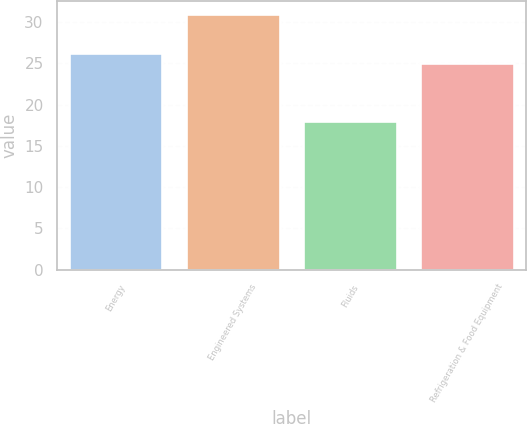Convert chart. <chart><loc_0><loc_0><loc_500><loc_500><bar_chart><fcel>Energy<fcel>Engineered Systems<fcel>Fluids<fcel>Refrigeration & Food Equipment<nl><fcel>26.3<fcel>31<fcel>18<fcel>25<nl></chart> 